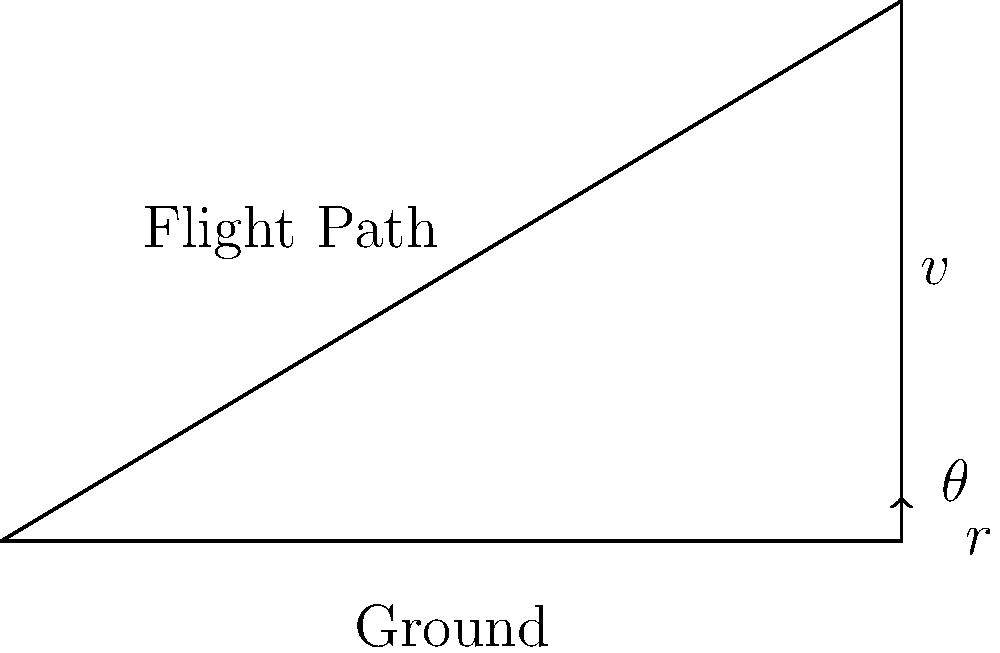A fighter jet is flying at a velocity of 250 m/s with a climb rate of 50 m/s. Calculate the angle of the jet's flight path relative to the ground. Round your answer to the nearest degree. To solve this problem, we need to use trigonometry. The flight path angle can be calculated using the arctangent function. Here's the step-by-step solution:

1. Identify the given information:
   - Velocity (v) = 250 m/s
   - Climb rate (r) = 50 m/s

2. The flight path angle (θ) is the angle between the velocity vector and the horizontal plane.

3. We can consider this as a right triangle, where:
   - The hypotenuse is the velocity vector (v)
   - The opposite side is the climb rate (r)
   - The adjacent side is the horizontal component of the velocity

4. The tangent of the angle is the ratio of the opposite side to the adjacent side:
   
   $$\tan(\theta) = \frac{\text{opposite}}{\text{adjacent}} = \frac{\text{climb rate}}{\text{horizontal velocity}}$$

5. We don't know the horizontal velocity directly, but we can use the Pythagorean theorem to find it:
   
   $$\text{horizontal velocity} = \sqrt{v^2 - r^2} = \sqrt{250^2 - 50^2} = \sqrt{62500 - 2500} = \sqrt{60000} \approx 244.95 \text{ m/s}$$

6. Now we can calculate the tangent of the angle:
   
   $$\tan(\theta) = \frac{50}{244.95} \approx 0.2041$$

7. To find the angle, we use the arctangent (inverse tangent) function:
   
   $$\theta = \arctan(0.2041) \approx 11.54^\circ$$

8. Rounding to the nearest degree:
   
   $$\theta \approx 12^\circ$$
Answer: 12° 